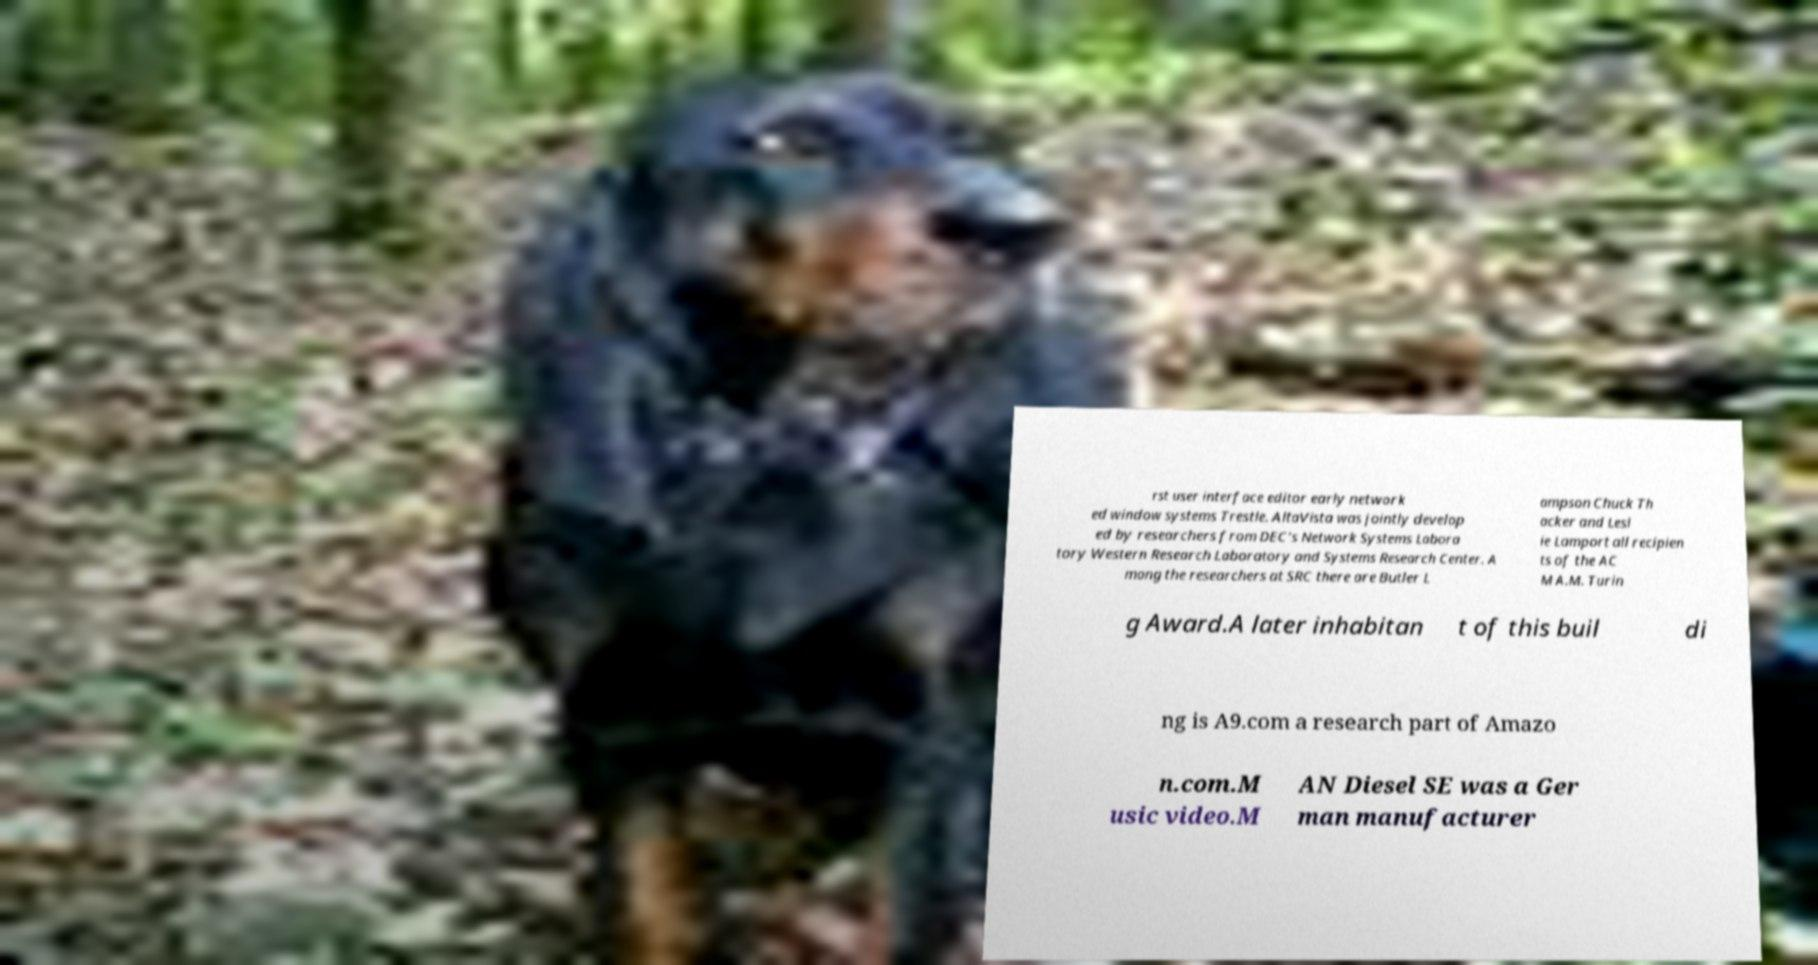Can you accurately transcribe the text from the provided image for me? rst user interface editor early network ed window systems Trestle. AltaVista was jointly develop ed by researchers from DEC's Network Systems Labora tory Western Research Laboratory and Systems Research Center. A mong the researchers at SRC there are Butler L ampson Chuck Th acker and Lesl ie Lamport all recipien ts of the AC M A.M. Turin g Award.A later inhabitan t of this buil di ng is A9.com a research part of Amazo n.com.M usic video.M AN Diesel SE was a Ger man manufacturer 